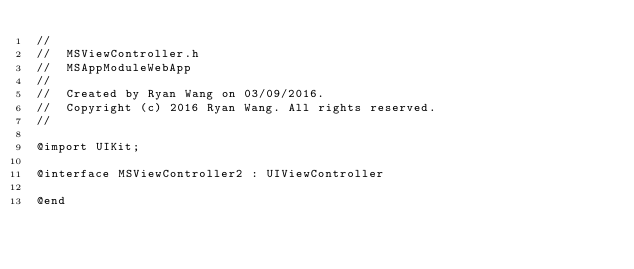<code> <loc_0><loc_0><loc_500><loc_500><_C_>//
//  MSViewController.h
//  MSAppModuleWebApp
//
//  Created by Ryan Wang on 03/09/2016.
//  Copyright (c) 2016 Ryan Wang. All rights reserved.
//

@import UIKit;

@interface MSViewController2 : UIViewController

@end
</code> 